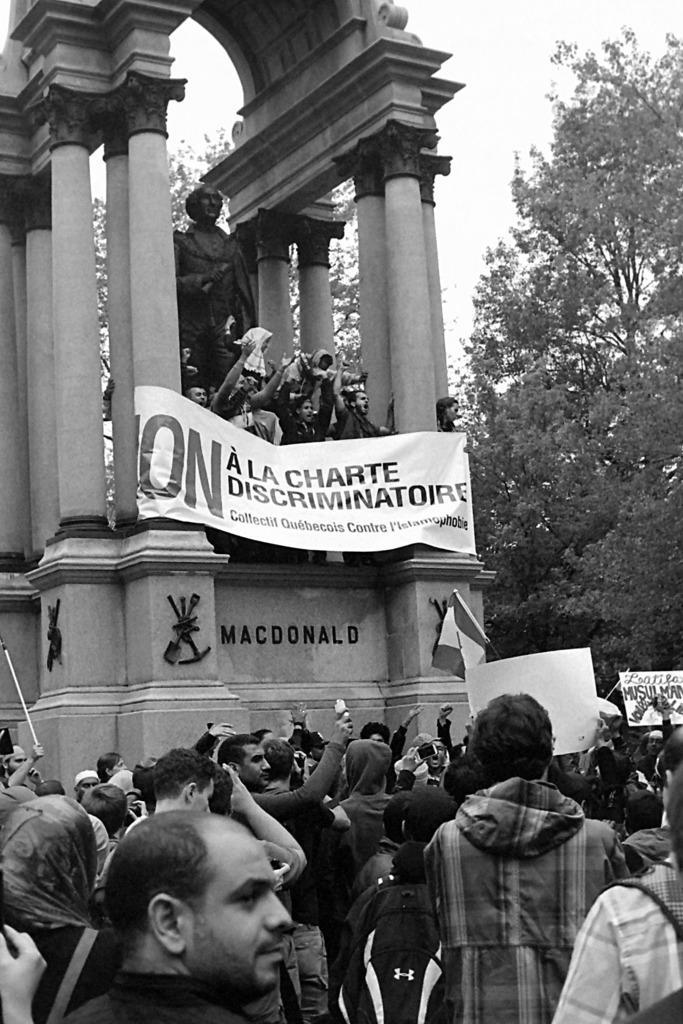Describe this image in one or two sentences. This is the black and white picture, there are many people on the land protesting holding banners and flags and behind there is a statue with people standing in front of it with banners, on the right side there is a tree. 